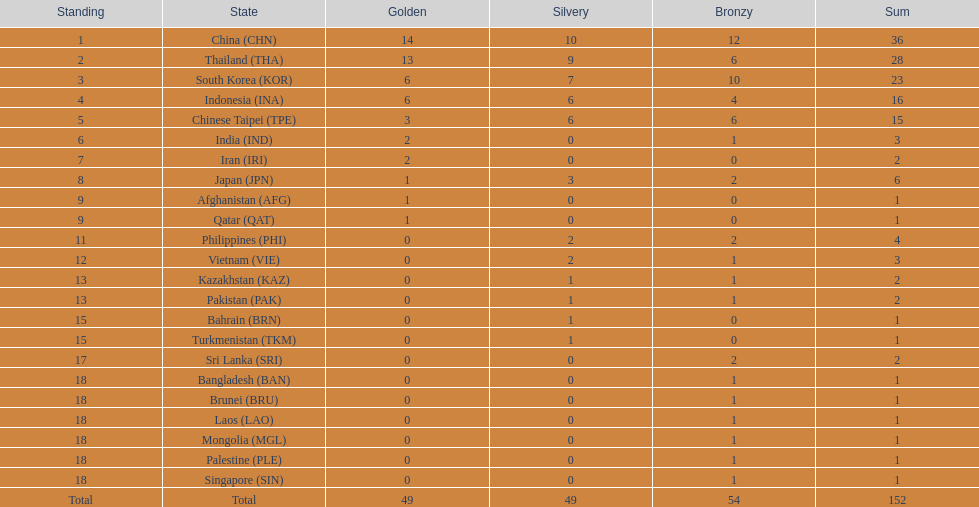How many countries obtained over 5 gold medals? 4. 